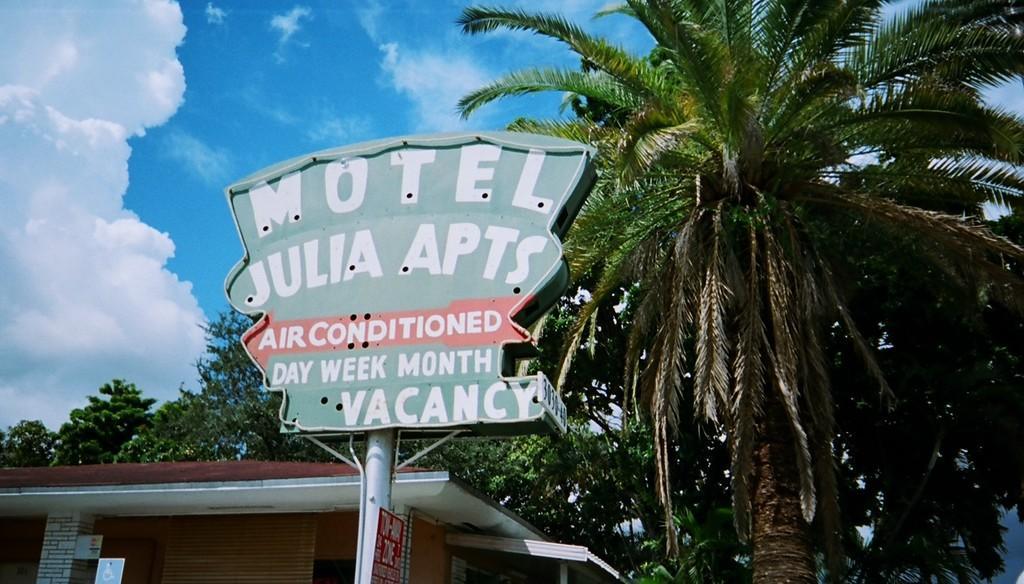Please provide a concise description of this image. In this image on the right, there are trees. At the bottom there is a house. In the middle there is a board, text, pole, poster. In the background there are trees, sky and clouds. 